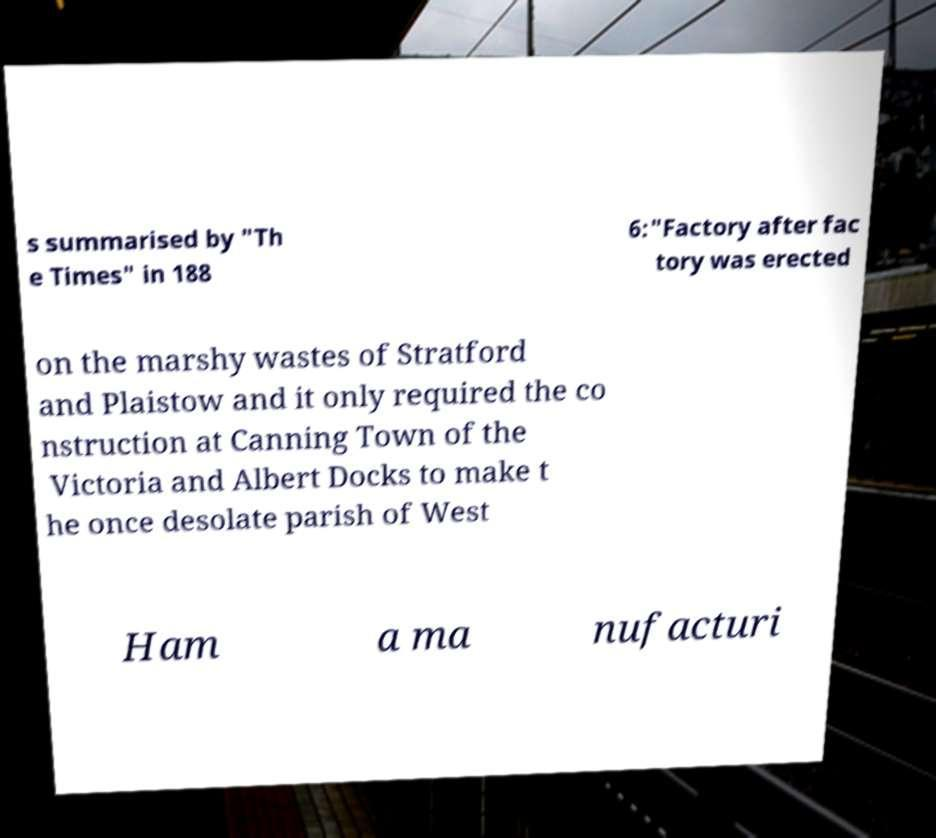Please read and relay the text visible in this image. What does it say? s summarised by "Th e Times" in 188 6:"Factory after fac tory was erected on the marshy wastes of Stratford and Plaistow and it only required the co nstruction at Canning Town of the Victoria and Albert Docks to make t he once desolate parish of West Ham a ma nufacturi 